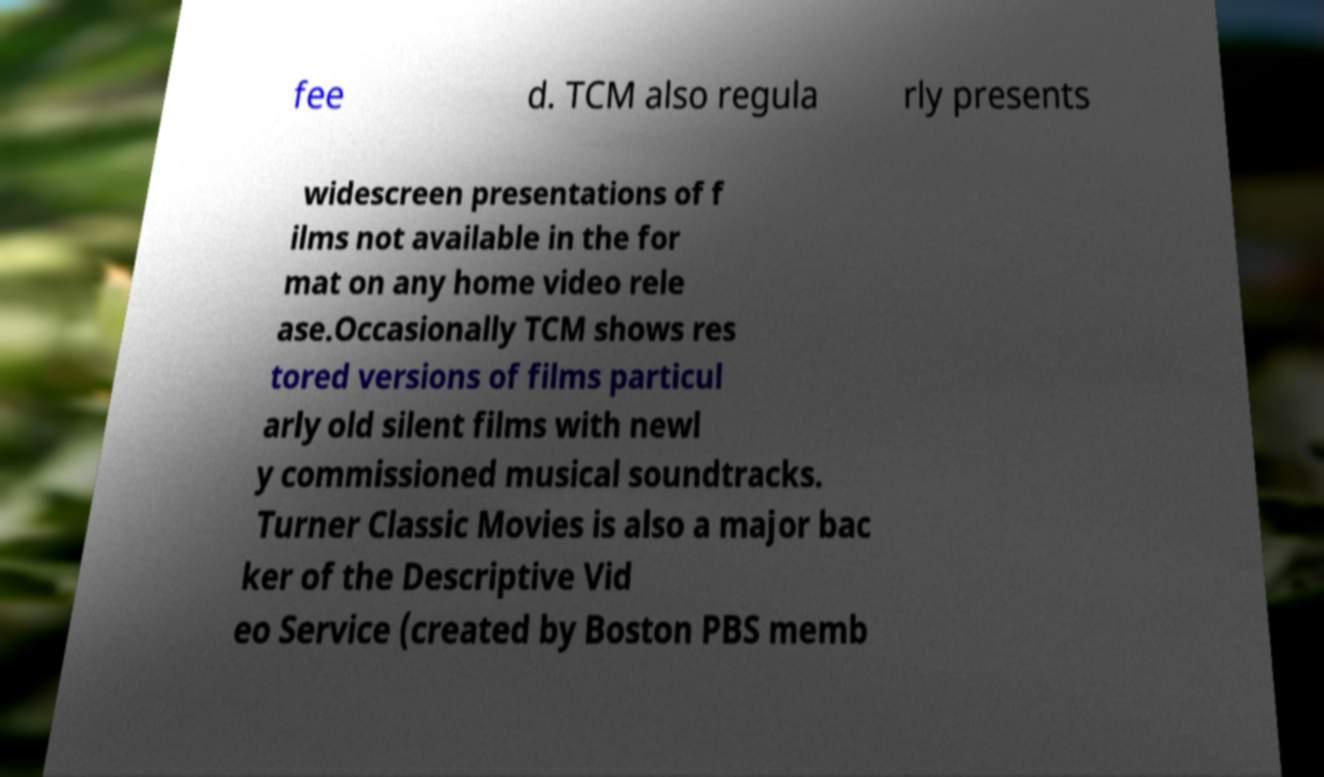There's text embedded in this image that I need extracted. Can you transcribe it verbatim? fee d. TCM also regula rly presents widescreen presentations of f ilms not available in the for mat on any home video rele ase.Occasionally TCM shows res tored versions of films particul arly old silent films with newl y commissioned musical soundtracks. Turner Classic Movies is also a major bac ker of the Descriptive Vid eo Service (created by Boston PBS memb 